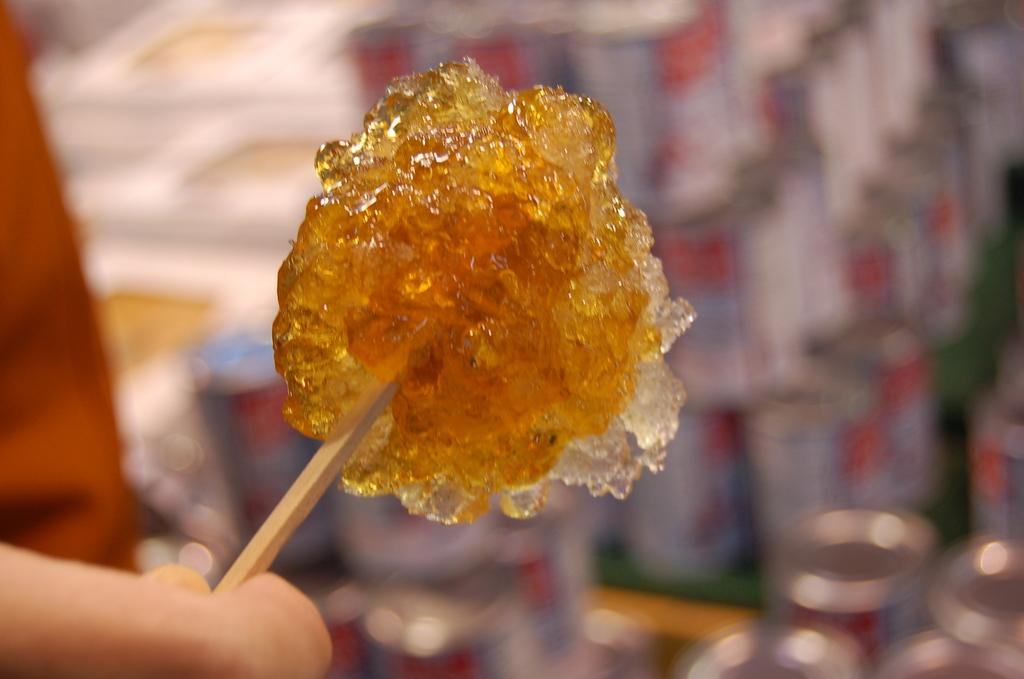What is the main subject in the foreground of the image? There is a candy-like object on a stick in the foreground of the image. Who is holding the candy-like object? The candy-like object is being held by a person. Can you describe the background of the image? The background of the image is blurred. What is the creator's name of the candy-like object in the image? There is no information about the creator of the candy-like object in the image. 